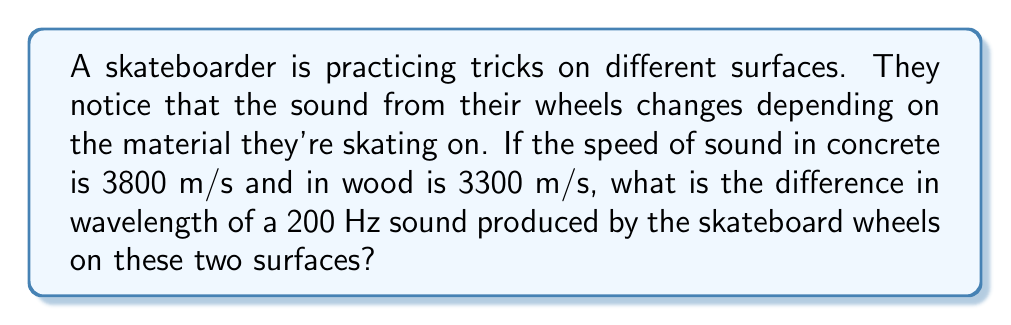Teach me how to tackle this problem. To solve this problem, we'll use the wave equation that relates wave speed ($v$), frequency ($f$), and wavelength ($\lambda$):

$$v = f \lambda$$

We'll solve for the wavelength on each surface and then find the difference.

1. For concrete:
   $$3800 = 200 \lambda_c$$
   $$\lambda_c = \frac{3800}{200} = 19 \text{ m}$$

2. For wood:
   $$3300 = 200 \lambda_w$$
   $$\lambda_w = \frac{3300}{200} = 16.5 \text{ m}$$

3. Difference in wavelength:
   $$\Delta \lambda = \lambda_c - \lambda_w = 19 - 16.5 = 2.5 \text{ m}$$
Answer: 2.5 m 